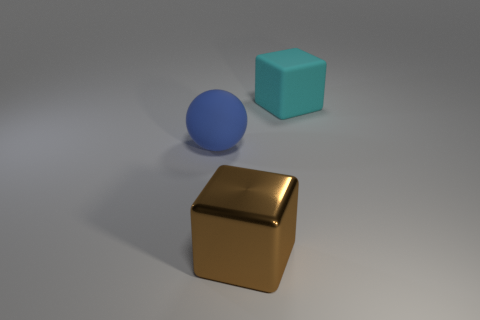Is there any other thing that has the same material as the large brown thing?
Your answer should be compact. No. What shape is the large rubber object on the left side of the big block that is on the left side of the object behind the rubber sphere?
Keep it short and to the point. Sphere. How many big red metallic things are the same shape as the brown metal thing?
Provide a short and direct response. 0. What number of big cubes are in front of the cube behind the large brown metallic thing?
Make the answer very short. 1. How many matte things are either tiny red objects or cyan objects?
Ensure brevity in your answer.  1. Are there any things that have the same material as the blue sphere?
Give a very brief answer. Yes. How many objects are either large matte objects on the right side of the matte sphere or blocks in front of the large blue matte sphere?
Offer a very short reply. 2. How many other things are there of the same color as the rubber sphere?
Keep it short and to the point. 0. What is the brown cube made of?
Ensure brevity in your answer.  Metal. Do the matte object that is left of the cyan thing and the cyan matte block have the same size?
Your answer should be compact. Yes. 